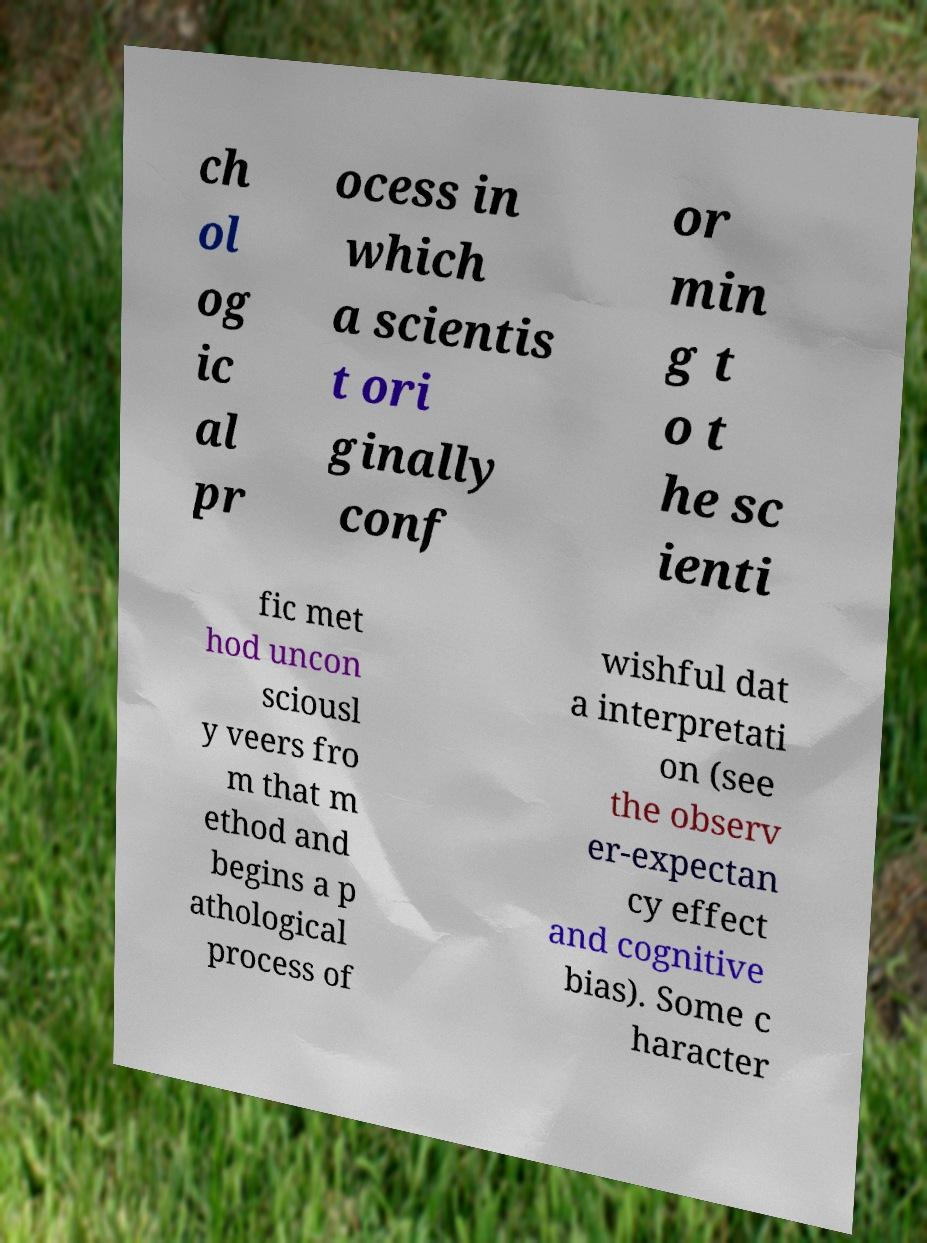What messages or text are displayed in this image? I need them in a readable, typed format. ch ol og ic al pr ocess in which a scientis t ori ginally conf or min g t o t he sc ienti fic met hod uncon sciousl y veers fro m that m ethod and begins a p athological process of wishful dat a interpretati on (see the observ er-expectan cy effect and cognitive bias). Some c haracter 